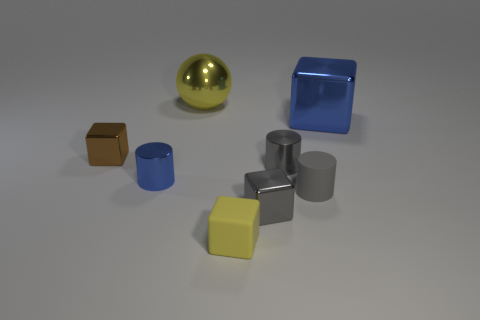Subtract 1 cubes. How many cubes are left? 3 Add 1 yellow metal spheres. How many objects exist? 9 Subtract all cylinders. How many objects are left? 5 Add 3 tiny shiny objects. How many tiny shiny objects exist? 7 Subtract 1 brown cubes. How many objects are left? 7 Subtract all matte blocks. Subtract all small brown matte cylinders. How many objects are left? 7 Add 7 tiny yellow matte objects. How many tiny yellow matte objects are left? 8 